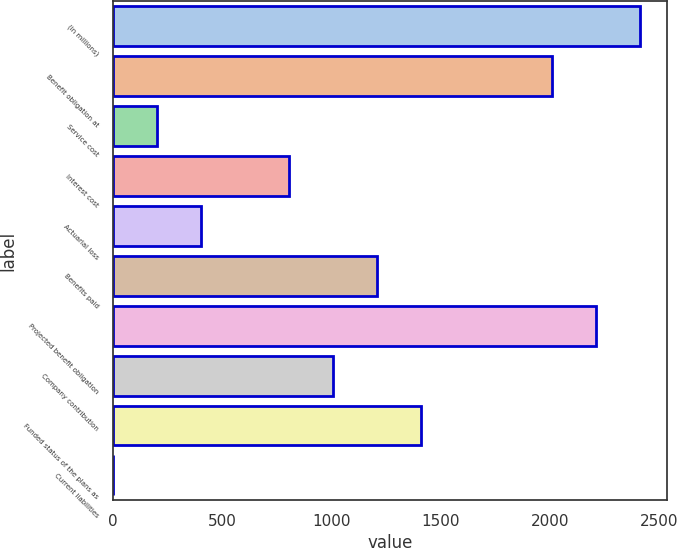Convert chart to OTSL. <chart><loc_0><loc_0><loc_500><loc_500><bar_chart><fcel>(in millions)<fcel>Benefit obligation at<fcel>Service cost<fcel>Interest cost<fcel>Actuarial loss<fcel>Benefits paid<fcel>Projected benefit obligation<fcel>Company contribution<fcel>Funded status of the plans as<fcel>Current liabilities<nl><fcel>2415.48<fcel>2013<fcel>201.84<fcel>805.56<fcel>403.08<fcel>1208.04<fcel>2214.24<fcel>1006.8<fcel>1409.28<fcel>0.6<nl></chart> 